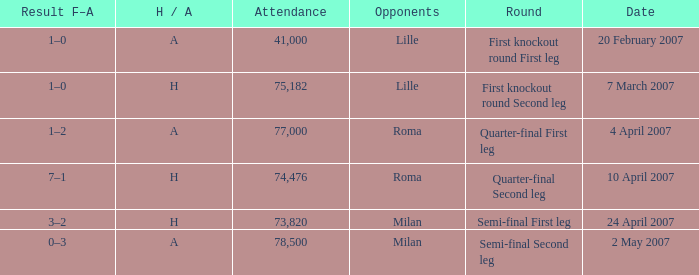Which round has an Opponent of lille, and a H / A of h? First knockout round Second leg. 